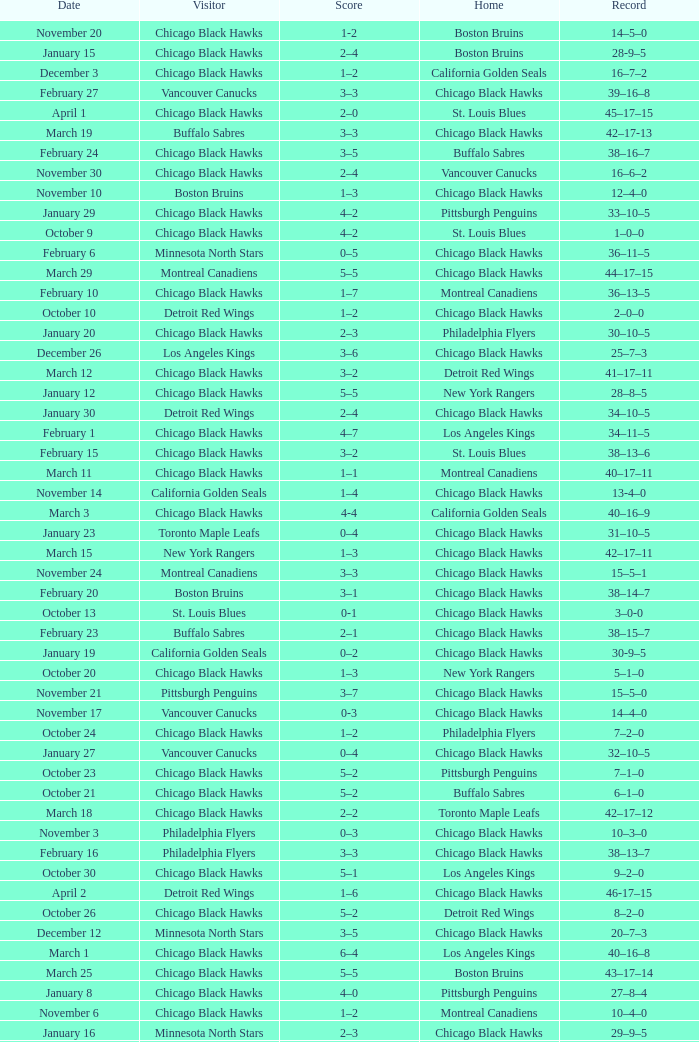Write the full table. {'header': ['Date', 'Visitor', 'Score', 'Home', 'Record'], 'rows': [['November 20', 'Chicago Black Hawks', '1-2', 'Boston Bruins', '14–5–0'], ['January 15', 'Chicago Black Hawks', '2–4', 'Boston Bruins', '28-9–5'], ['December 3', 'Chicago Black Hawks', '1–2', 'California Golden Seals', '16–7–2'], ['February 27', 'Vancouver Canucks', '3–3', 'Chicago Black Hawks', '39–16–8'], ['April 1', 'Chicago Black Hawks', '2–0', 'St. Louis Blues', '45–17–15'], ['March 19', 'Buffalo Sabres', '3–3', 'Chicago Black Hawks', '42–17-13'], ['February 24', 'Chicago Black Hawks', '3–5', 'Buffalo Sabres', '38–16–7'], ['November 30', 'Chicago Black Hawks', '2–4', 'Vancouver Canucks', '16–6–2'], ['November 10', 'Boston Bruins', '1–3', 'Chicago Black Hawks', '12–4–0'], ['January 29', 'Chicago Black Hawks', '4–2', 'Pittsburgh Penguins', '33–10–5'], ['October 9', 'Chicago Black Hawks', '4–2', 'St. Louis Blues', '1–0–0'], ['February 6', 'Minnesota North Stars', '0–5', 'Chicago Black Hawks', '36–11–5'], ['March 29', 'Montreal Canadiens', '5–5', 'Chicago Black Hawks', '44–17–15'], ['February 10', 'Chicago Black Hawks', '1–7', 'Montreal Canadiens', '36–13–5'], ['October 10', 'Detroit Red Wings', '1–2', 'Chicago Black Hawks', '2–0–0'], ['January 20', 'Chicago Black Hawks', '2–3', 'Philadelphia Flyers', '30–10–5'], ['December 26', 'Los Angeles Kings', '3–6', 'Chicago Black Hawks', '25–7–3'], ['March 12', 'Chicago Black Hawks', '3–2', 'Detroit Red Wings', '41–17–11'], ['January 12', 'Chicago Black Hawks', '5–5', 'New York Rangers', '28–8–5'], ['January 30', 'Detroit Red Wings', '2–4', 'Chicago Black Hawks', '34–10–5'], ['February 1', 'Chicago Black Hawks', '4–7', 'Los Angeles Kings', '34–11–5'], ['February 15', 'Chicago Black Hawks', '3–2', 'St. Louis Blues', '38–13–6'], ['March 11', 'Chicago Black Hawks', '1–1', 'Montreal Canadiens', '40–17–11'], ['November 14', 'California Golden Seals', '1–4', 'Chicago Black Hawks', '13-4–0'], ['March 3', 'Chicago Black Hawks', '4-4', 'California Golden Seals', '40–16–9'], ['January 23', 'Toronto Maple Leafs', '0–4', 'Chicago Black Hawks', '31–10–5'], ['March 15', 'New York Rangers', '1–3', 'Chicago Black Hawks', '42–17–11'], ['November 24', 'Montreal Canadiens', '3–3', 'Chicago Black Hawks', '15–5–1'], ['February 20', 'Boston Bruins', '3–1', 'Chicago Black Hawks', '38–14–7'], ['October 13', 'St. Louis Blues', '0-1', 'Chicago Black Hawks', '3–0-0'], ['February 23', 'Buffalo Sabres', '2–1', 'Chicago Black Hawks', '38–15–7'], ['January 19', 'California Golden Seals', '0–2', 'Chicago Black Hawks', '30-9–5'], ['October 20', 'Chicago Black Hawks', '1–3', 'New York Rangers', '5–1–0'], ['November 21', 'Pittsburgh Penguins', '3–7', 'Chicago Black Hawks', '15–5–0'], ['November 17', 'Vancouver Canucks', '0-3', 'Chicago Black Hawks', '14–4–0'], ['October 24', 'Chicago Black Hawks', '1–2', 'Philadelphia Flyers', '7–2–0'], ['January 27', 'Vancouver Canucks', '0–4', 'Chicago Black Hawks', '32–10–5'], ['October 23', 'Chicago Black Hawks', '5–2', 'Pittsburgh Penguins', '7–1–0'], ['October 21', 'Chicago Black Hawks', '5–2', 'Buffalo Sabres', '6–1–0'], ['March 18', 'Chicago Black Hawks', '2–2', 'Toronto Maple Leafs', '42–17–12'], ['November 3', 'Philadelphia Flyers', '0–3', 'Chicago Black Hawks', '10–3–0'], ['February 16', 'Philadelphia Flyers', '3–3', 'Chicago Black Hawks', '38–13–7'], ['October 30', 'Chicago Black Hawks', '5–1', 'Los Angeles Kings', '9–2–0'], ['April 2', 'Detroit Red Wings', '1–6', 'Chicago Black Hawks', '46-17–15'], ['October 26', 'Chicago Black Hawks', '5–2', 'Detroit Red Wings', '8–2–0'], ['December 12', 'Minnesota North Stars', '3–5', 'Chicago Black Hawks', '20–7–3'], ['March 1', 'Chicago Black Hawks', '6–4', 'Los Angeles Kings', '40–16–8'], ['March 25', 'Chicago Black Hawks', '5–5', 'Boston Bruins', '43–17–14'], ['January 8', 'Chicago Black Hawks', '4–0', 'Pittsburgh Penguins', '27–8–4'], ['November 6', 'Chicago Black Hawks', '1–2', 'Montreal Canadiens', '10–4–0'], ['January 16', 'Minnesota North Stars', '2–3', 'Chicago Black Hawks', '29–9–5'], ['January 2', 'Philadelphia Flyers', '2–6', 'Chicago Black Hawks', '26–8–3'], ['December 19', 'St. Louis Blues', '0–2', 'Chicago Black Hawks', '23–7–3'], ['December 11', 'Chicago Black Hawks', '3–1', 'Toronto Maple Leafs', '19–7–3'], ['February 4', 'Chicago Black Hawks', '6–2', 'Vancouver Canucks', '35–11–5'], ['October 17', 'Los Angeles Kings', '0–4', 'Chicago Black Hawks', '5–0–0'], ['March 26', 'St. Louis Blues', '0–4', 'Chicago Black Hawks', '44–17–14'], ['February 26', 'California Golden Seals', '0–3', 'Chicago Black Hawks', '39–16–7'], ['December 9', 'Chicago Black Hawks', '3-1', 'Buffalo Sabres', '18–7–3'], ['February 12', 'Chicago Black Hawks', '3-3', 'Detroit Red Wings', '36–13–6'], ['November 7', 'Pittsburgh Penguins', '1–4', 'Chicago Black Hawks', '11-4–0'], ['March 8', 'Chicago Black Hawks', '3–3', 'New York Rangers', '40–17–10'], ['October 31', 'Chicago Black Hawks', '2–6', 'Vancouver Canucks', '9–3–0'], ['March 23', 'Chicago Black Hawks', '4–2', 'Philadelphia Flyers', '43–17–13'], ['December 8', 'New York Rangers', '2–2', 'Chicago Black Hawks', '17–7–3'], ['February 9', 'Chicago Black Hawks', '1–4', 'New York Rangers', '36–12–5'], ['December 29', 'Boston Bruins', '5-1', 'Chicago Black Hawks', '25–8–3'], ['December 18', 'Chicago Black Hawks', '4–1', 'Minnesota North Stars', '22–7–3'], ['February 13', 'Toronto Maple Leafs', '1–3', 'Chicago Black Hawks', '37–13–6'], ['December 5', 'Los Angeles Kings', '0-7', 'Chicago Black Hawks', '17–7–2'], ['November 28', 'Toronto Maple Leafs', '1-4', 'Chicago Black Hawks', '16–5–2'], ['March 5', 'Chicago Black Hawks', '1–2', 'Minnesota North Stars', '40–17–9'], ['January 5', 'Pittsburgh Penguins', '3–3', 'Chicago Black Hawks', '26–8–4'], ['November 27', 'Chicago Black Hawks', '3–3', 'Toronto Maple Leafs', '15–5–2'], ['January 9', 'Montreal Canadiens', '2–5', 'Chicago Black Hawks', '28–8–4'], ['October 16', 'Chicago Black Hawks', '3–2', 'Minnesota North Stars', '4–0–0'], ['December 15', 'Buffalo Sabres', '1–2', 'Chicago Black Hawks', '21–7–3'], ['December 22', 'Chicago Black Hawks', '4–1', 'California Golden Seals', '24–7–3']]} What is the Record of the February 26 date? 39–16–7. 